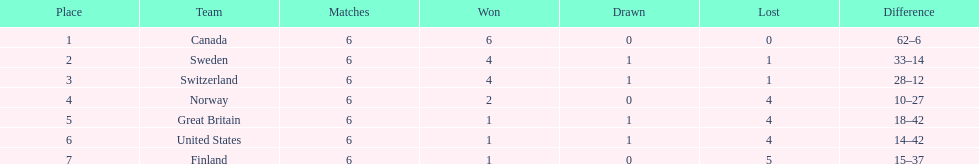What team placed next after sweden? Switzerland. 